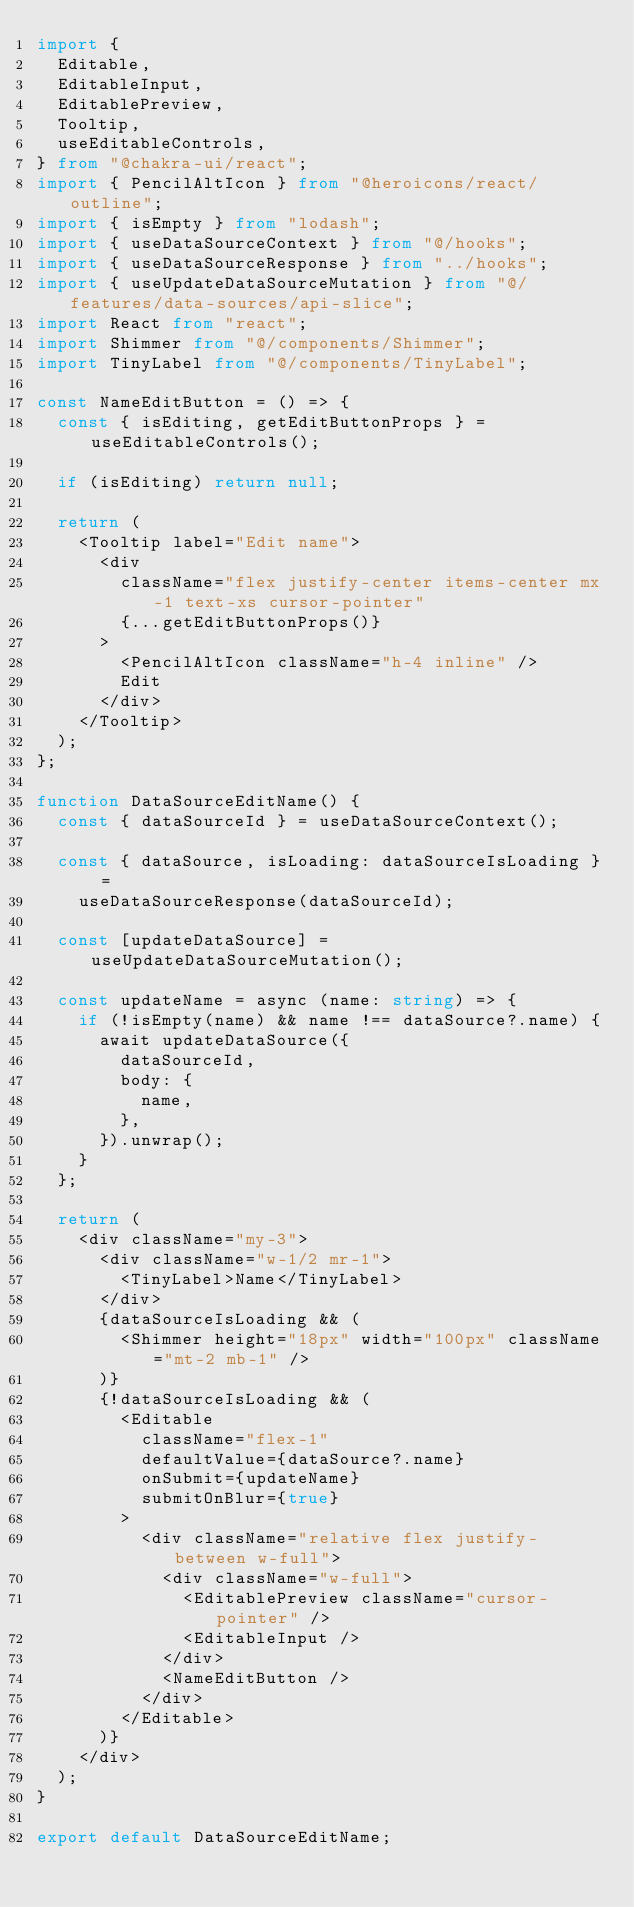<code> <loc_0><loc_0><loc_500><loc_500><_TypeScript_>import {
  Editable,
  EditableInput,
  EditablePreview,
  Tooltip,
  useEditableControls,
} from "@chakra-ui/react";
import { PencilAltIcon } from "@heroicons/react/outline";
import { isEmpty } from "lodash";
import { useDataSourceContext } from "@/hooks";
import { useDataSourceResponse } from "../hooks";
import { useUpdateDataSourceMutation } from "@/features/data-sources/api-slice";
import React from "react";
import Shimmer from "@/components/Shimmer";
import TinyLabel from "@/components/TinyLabel";

const NameEditButton = () => {
  const { isEditing, getEditButtonProps } = useEditableControls();

  if (isEditing) return null;

  return (
    <Tooltip label="Edit name">
      <div
        className="flex justify-center items-center mx-1 text-xs cursor-pointer"
        {...getEditButtonProps()}
      >
        <PencilAltIcon className="h-4 inline" />
        Edit
      </div>
    </Tooltip>
  );
};

function DataSourceEditName() {
  const { dataSourceId } = useDataSourceContext();

  const { dataSource, isLoading: dataSourceIsLoading } =
    useDataSourceResponse(dataSourceId);

  const [updateDataSource] = useUpdateDataSourceMutation();

  const updateName = async (name: string) => {
    if (!isEmpty(name) && name !== dataSource?.name) {
      await updateDataSource({
        dataSourceId,
        body: {
          name,
        },
      }).unwrap();
    }
  };

  return (
    <div className="my-3">
      <div className="w-1/2 mr-1">
        <TinyLabel>Name</TinyLabel>
      </div>
      {dataSourceIsLoading && (
        <Shimmer height="18px" width="100px" className="mt-2 mb-1" />
      )}
      {!dataSourceIsLoading && (
        <Editable
          className="flex-1"
          defaultValue={dataSource?.name}
          onSubmit={updateName}
          submitOnBlur={true}
        >
          <div className="relative flex justify-between w-full">
            <div className="w-full">
              <EditablePreview className="cursor-pointer" />
              <EditableInput />
            </div>
            <NameEditButton />
          </div>
        </Editable>
      )}
    </div>
  );
}

export default DataSourceEditName;
</code> 